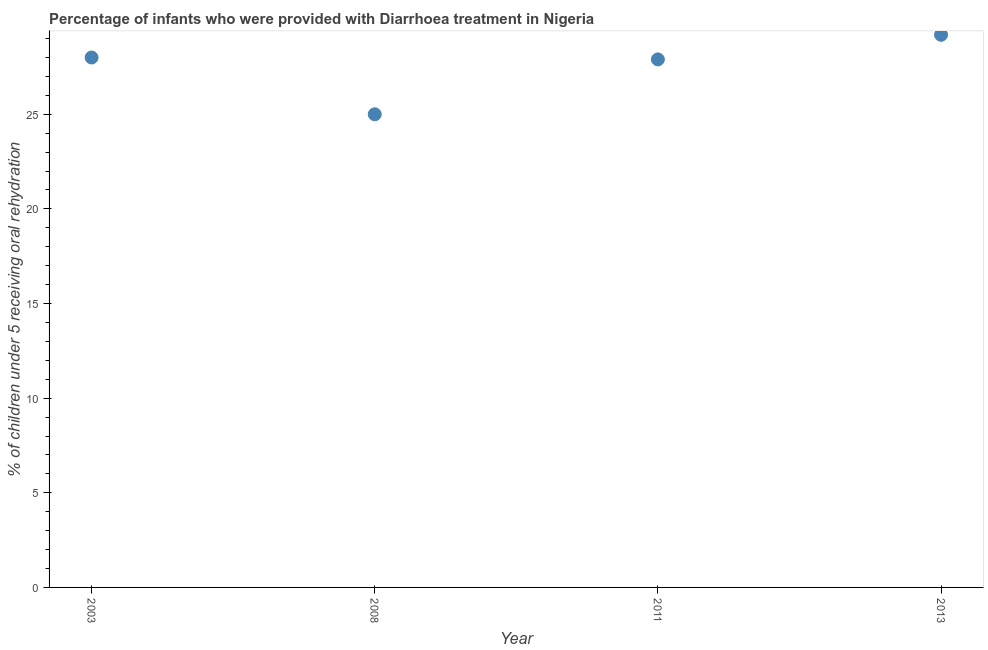Across all years, what is the maximum percentage of children who were provided with treatment diarrhoea?
Keep it short and to the point. 29.2. In which year was the percentage of children who were provided with treatment diarrhoea maximum?
Make the answer very short. 2013. What is the sum of the percentage of children who were provided with treatment diarrhoea?
Your answer should be very brief. 110.1. What is the difference between the percentage of children who were provided with treatment diarrhoea in 2011 and 2013?
Make the answer very short. -1.3. What is the average percentage of children who were provided with treatment diarrhoea per year?
Provide a succinct answer. 27.53. What is the median percentage of children who were provided with treatment diarrhoea?
Offer a terse response. 27.95. Do a majority of the years between 2013 and 2008 (inclusive) have percentage of children who were provided with treatment diarrhoea greater than 4 %?
Give a very brief answer. No. What is the ratio of the percentage of children who were provided with treatment diarrhoea in 2011 to that in 2013?
Give a very brief answer. 0.96. Is the percentage of children who were provided with treatment diarrhoea in 2003 less than that in 2011?
Keep it short and to the point. No. Is the difference between the percentage of children who were provided with treatment diarrhoea in 2011 and 2013 greater than the difference between any two years?
Ensure brevity in your answer.  No. What is the difference between the highest and the second highest percentage of children who were provided with treatment diarrhoea?
Give a very brief answer. 1.2. Is the sum of the percentage of children who were provided with treatment diarrhoea in 2003 and 2011 greater than the maximum percentage of children who were provided with treatment diarrhoea across all years?
Your answer should be very brief. Yes. What is the difference between the highest and the lowest percentage of children who were provided with treatment diarrhoea?
Ensure brevity in your answer.  4.2. Does the percentage of children who were provided with treatment diarrhoea monotonically increase over the years?
Give a very brief answer. No. What is the title of the graph?
Keep it short and to the point. Percentage of infants who were provided with Diarrhoea treatment in Nigeria. What is the label or title of the Y-axis?
Make the answer very short. % of children under 5 receiving oral rehydration. What is the % of children under 5 receiving oral rehydration in 2008?
Provide a succinct answer. 25. What is the % of children under 5 receiving oral rehydration in 2011?
Offer a terse response. 27.9. What is the % of children under 5 receiving oral rehydration in 2013?
Keep it short and to the point. 29.2. What is the difference between the % of children under 5 receiving oral rehydration in 2003 and 2008?
Your answer should be very brief. 3. What is the difference between the % of children under 5 receiving oral rehydration in 2008 and 2013?
Provide a succinct answer. -4.2. What is the difference between the % of children under 5 receiving oral rehydration in 2011 and 2013?
Provide a short and direct response. -1.3. What is the ratio of the % of children under 5 receiving oral rehydration in 2003 to that in 2008?
Make the answer very short. 1.12. What is the ratio of the % of children under 5 receiving oral rehydration in 2003 to that in 2013?
Your answer should be very brief. 0.96. What is the ratio of the % of children under 5 receiving oral rehydration in 2008 to that in 2011?
Provide a succinct answer. 0.9. What is the ratio of the % of children under 5 receiving oral rehydration in 2008 to that in 2013?
Keep it short and to the point. 0.86. What is the ratio of the % of children under 5 receiving oral rehydration in 2011 to that in 2013?
Make the answer very short. 0.95. 